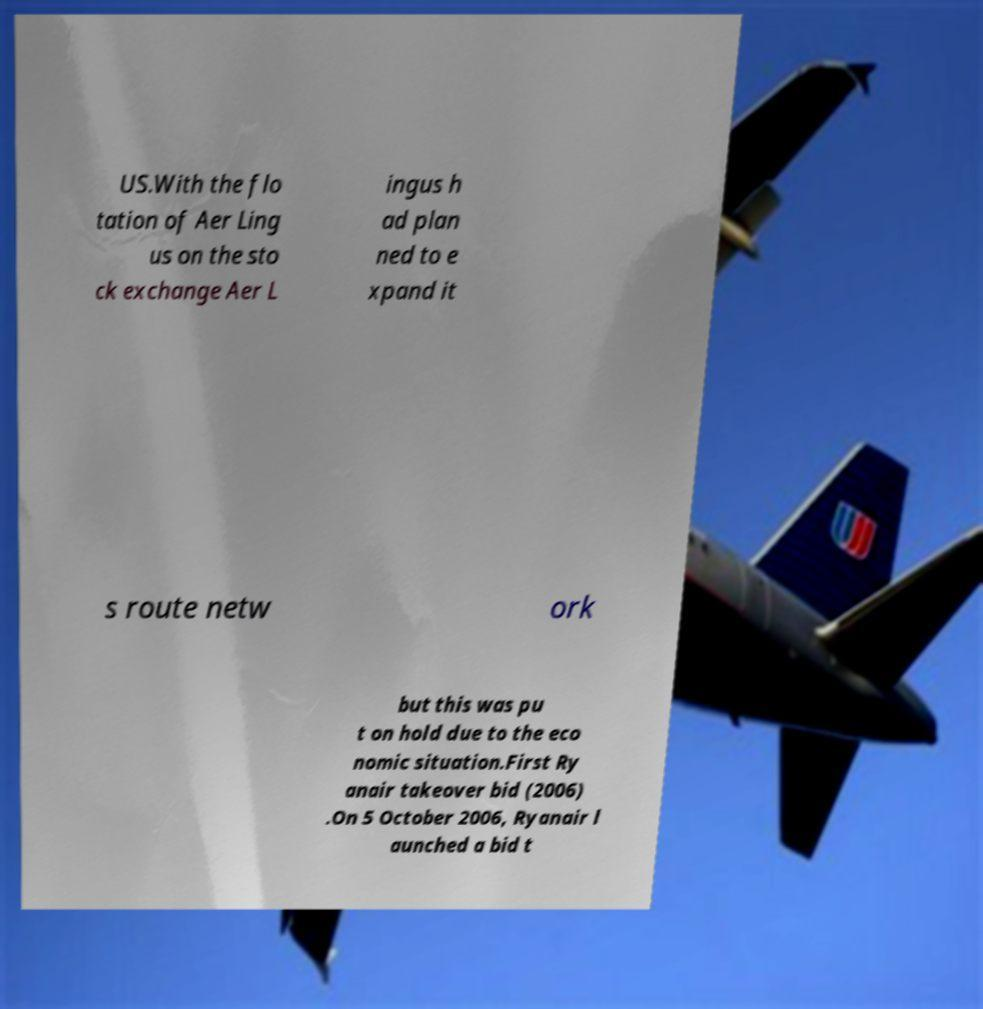Could you extract and type out the text from this image? US.With the flo tation of Aer Ling us on the sto ck exchange Aer L ingus h ad plan ned to e xpand it s route netw ork but this was pu t on hold due to the eco nomic situation.First Ry anair takeover bid (2006) .On 5 October 2006, Ryanair l aunched a bid t 